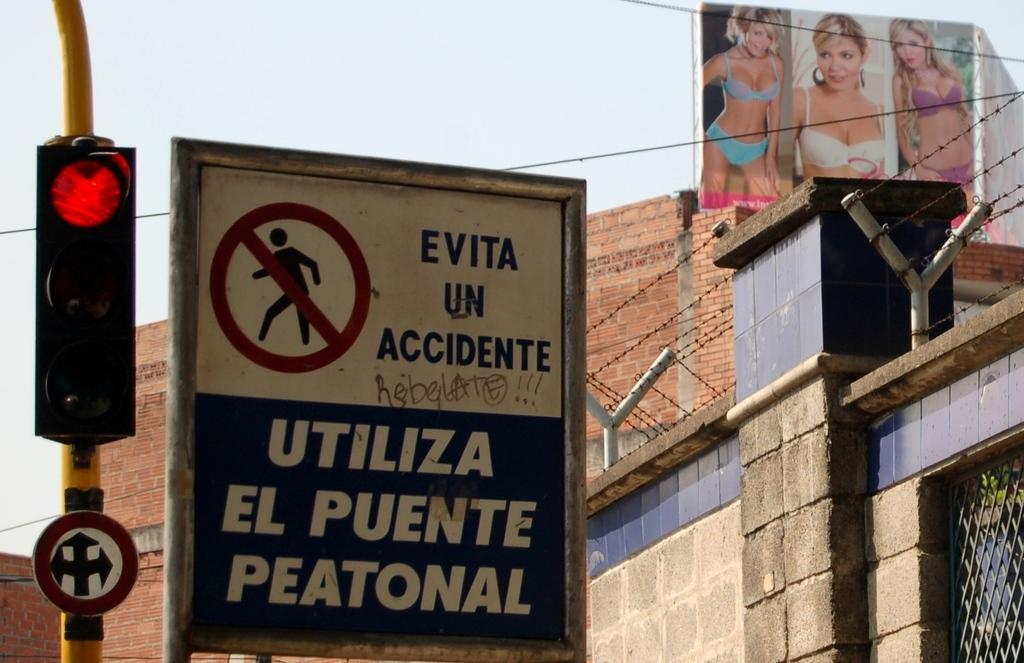Can you describe this image briefly? In this picture I can see a board on which there is something written and behind it I see the traffic signal on a pole and on the right side of this board I see the fencing. In the background I see the sky and on the top right of this image I see a hoarding on which there are pictures of women. 